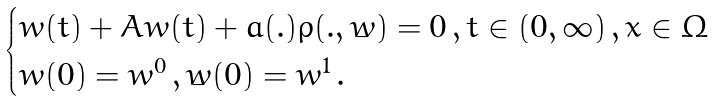Convert formula to latex. <formula><loc_0><loc_0><loc_500><loc_500>\begin{cases} \ddot { w } ( t ) + A w ( t ) + a ( . ) \rho ( . , \dot { w } ) = 0 \, , t \in ( 0 , \infty ) \, , x \in \Omega \\ w ( 0 ) = w ^ { 0 } \, , \dot { w } ( 0 ) = w ^ { 1 } \, . \end{cases}</formula> 